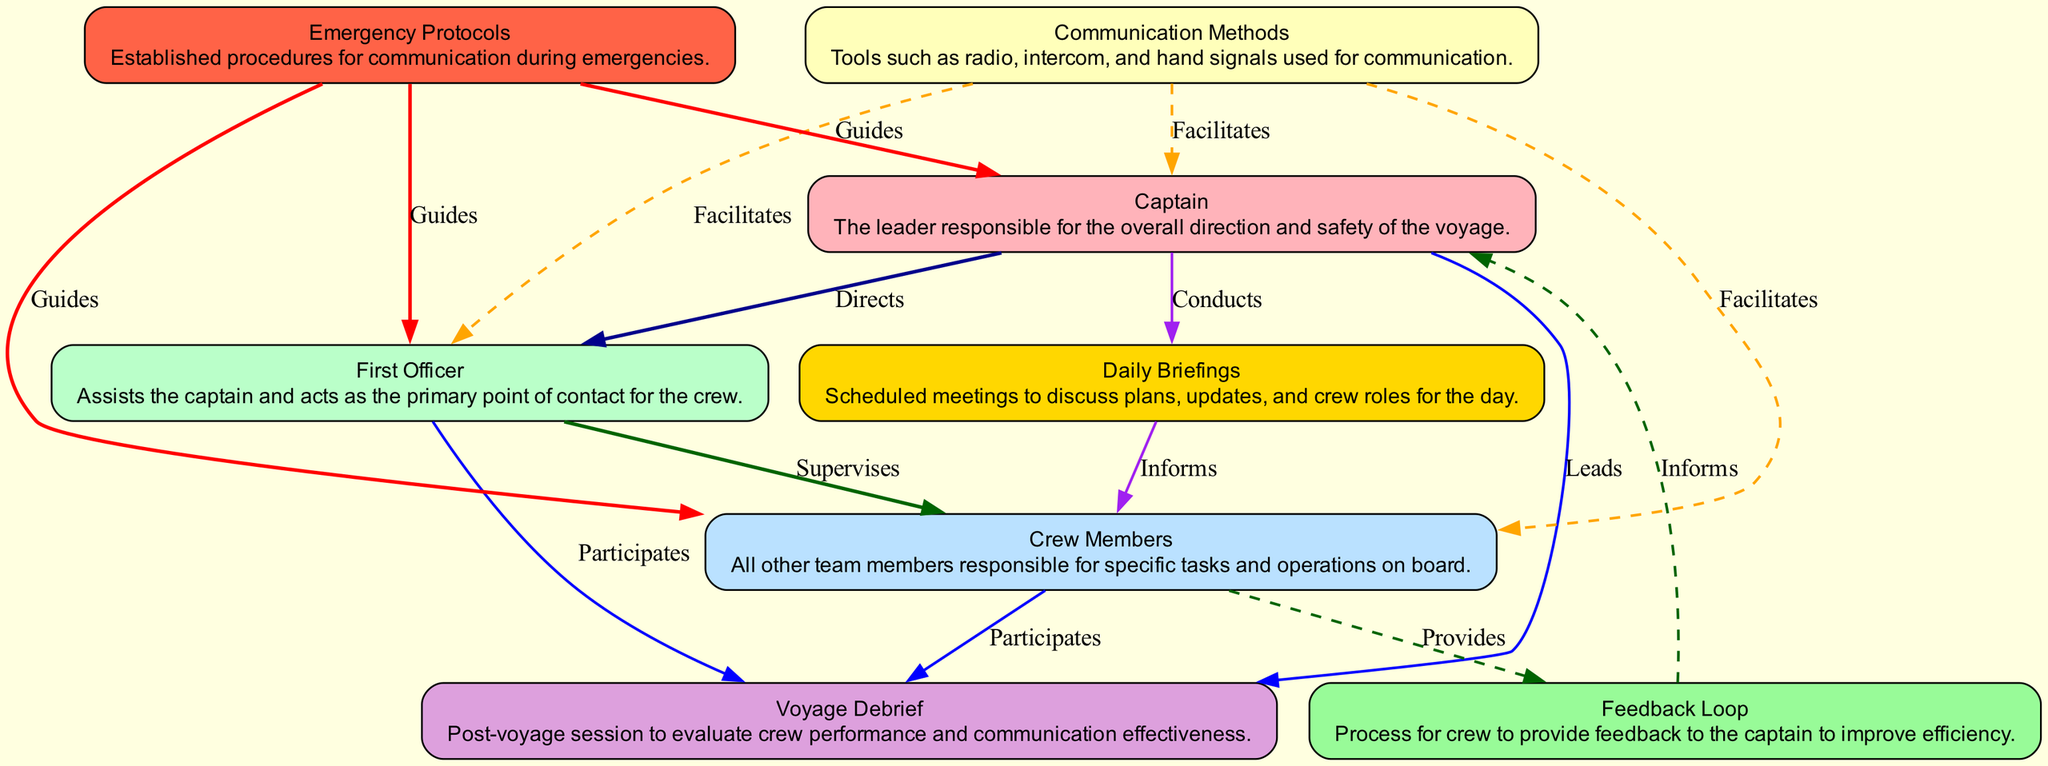What is the main role of the Captain? The diagram describes the Captain as "The leader responsible for the overall direction and safety of the voyage." This is found in the description under the Captain node in the diagram.
Answer: Overall direction and safety How many communication methods are shown in the diagram? The diagram lists a single node labeled "Communication Methods," which encompasses various tools for communication. Therefore, the count of distinct communication types isn't specified, indicating there is one node representing the concept.
Answer: One Who supervises the crew members? In the diagram, it clearly indicates that the First Officer "Supervises" the crew members, as depicted by the directed edge from the First Officer node to the Crew Members node.
Answer: First Officer What is the purpose of daily briefings? The "Daily Briefings" node states in its description that they are "Scheduled meetings to discuss plans, updates, and crew roles for the day." This purpose is directly conveyed through the description associated with this node.
Answer: Discuss plans and updates Which node provides feedback to the Captain? According to the diagram, the "Feedback Loop" node allows for feedback to be provided to the Captain. This relationship is shown via the directed edge pointing from Feedback Loop to Captain.
Answer: Feedback Loop What guides the crew members during emergencies? The diagram demonstrates that "Emergency Protocols" guides all crew members in emergencies, as shown by the directed edge from the Emergency Protocols node to the Crew Members node.
Answer: Emergency Protocols How many nodes are linked directly to the Captain? The diagram has three directed edges emanating from the Captain node, linking to the First Officer, Daily Briefings, and Voyage Debrief nodes. Counting these edges reveals there are three direct connections.
Answer: Three Which node participates in the voyage debrief? As per the diagram, the "Crew Members," "First Officer," and "Captain" all participate in the "Voyage Debrief," as indicated by the directed edges connecting to the Voyage Debrief node.
Answer: Crew Members, First Officer, Captain How do communication methods facilitate the crew's operations? The diagram shows that "Communication Methods" facilitate communication with the Captain, First Officer, and Crew Members through dashed lines, reflecting the dual direction of operation and support these methods provide.
Answer: Facilitate communication What does the feedback loop inform the Captain about? The feedback loop is designed to "Provide" information to the Captain, which likely pertains to crew performance and communication effectiveness as indicated by the directed edge from the Feedback Loop to the Captain.
Answer: Crew performance and communication effectiveness 